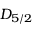Convert formula to latex. <formula><loc_0><loc_0><loc_500><loc_500>D _ { 5 / 2 }</formula> 